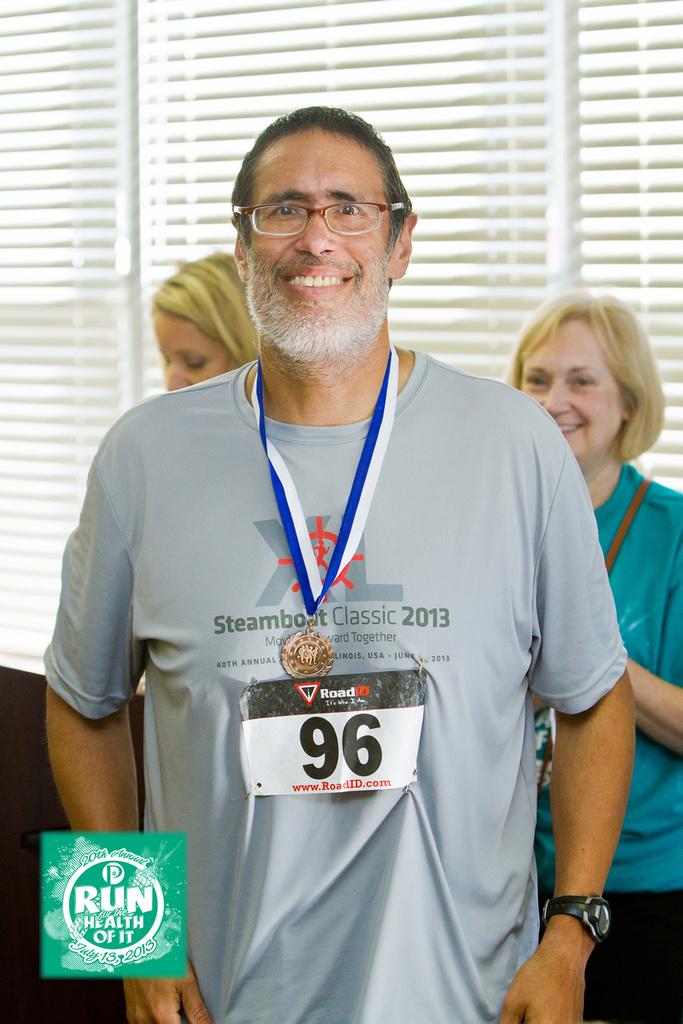What is the runner number?
Make the answer very short. 96. What year is on his t-shirt?
Ensure brevity in your answer.  2013. 